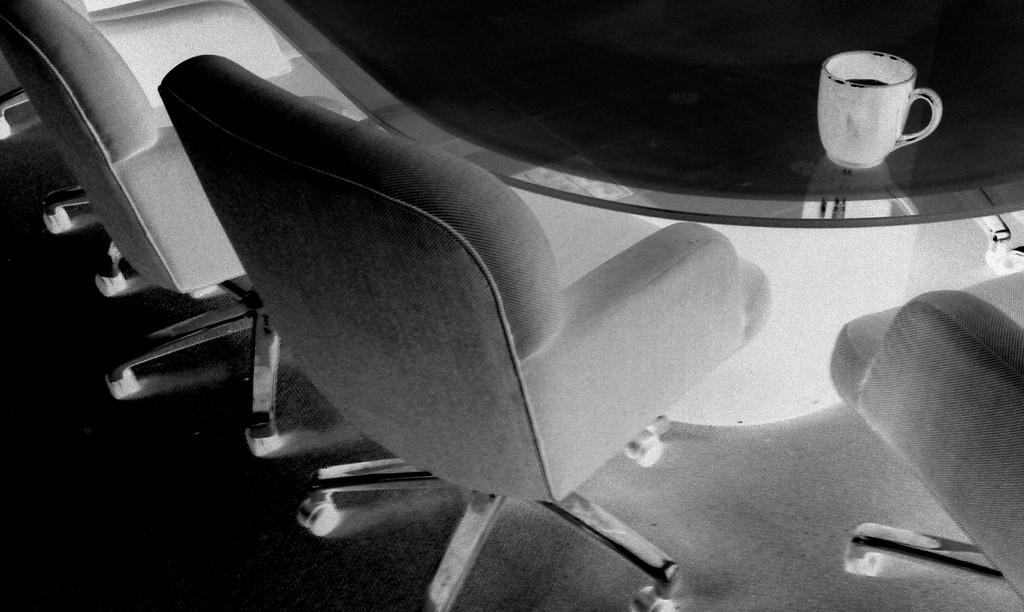What type of furniture is on the floor in the image? There are chairs on the floor in the image. What is placed on the table in the image? There is a cup with a drink on the table in the image. What is the color scheme of the image? The image is black and white. How many letters are visible on the chairs in the image? There are no letters visible on the chairs in the image. Can you see ants crawling on the table in the image? There are no ants present in the image. 